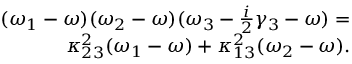<formula> <loc_0><loc_0><loc_500><loc_500>\begin{array} { r } { ( \omega _ { 1 } - \omega ) ( \omega _ { 2 } - \omega ) ( \omega _ { 3 } - \frac { i } { 2 } \gamma _ { 3 } - \omega ) = } \\ { \kappa _ { 2 3 } ^ { 2 } ( \omega _ { 1 } - \omega ) + \kappa _ { 1 3 } ^ { 2 } ( \omega _ { 2 } - \omega ) . } \end{array}</formula> 